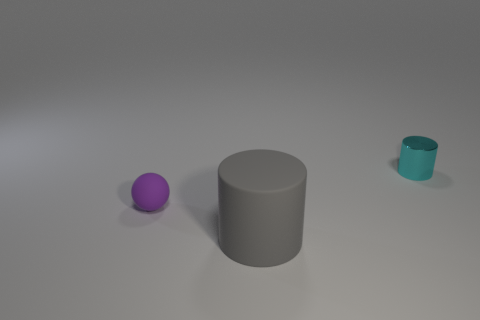Add 1 large green rubber spheres. How many objects exist? 4 Subtract all balls. How many objects are left? 2 Subtract all big purple rubber blocks. Subtract all big matte things. How many objects are left? 2 Add 2 balls. How many balls are left? 3 Add 2 small purple spheres. How many small purple spheres exist? 3 Subtract 1 cyan cylinders. How many objects are left? 2 